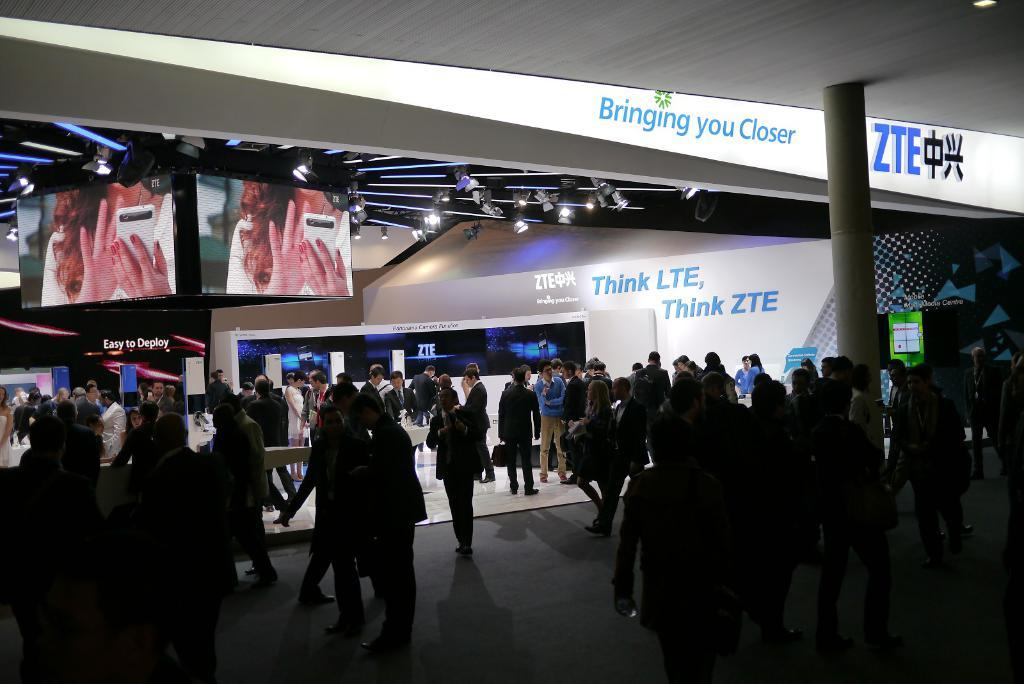How many people are in the image? There is a group of people standing in the image. What is the surface on which the people are standing? The people are standing on the floor. What is one prominent feature in the image? There is a pillar in the image. What can be seen in the background of the image? There are lights, screens, walls, and some objects visible in the background of the image. What country are the people in the image visiting? The image does not provide any information about the country or location where the people are standing. 